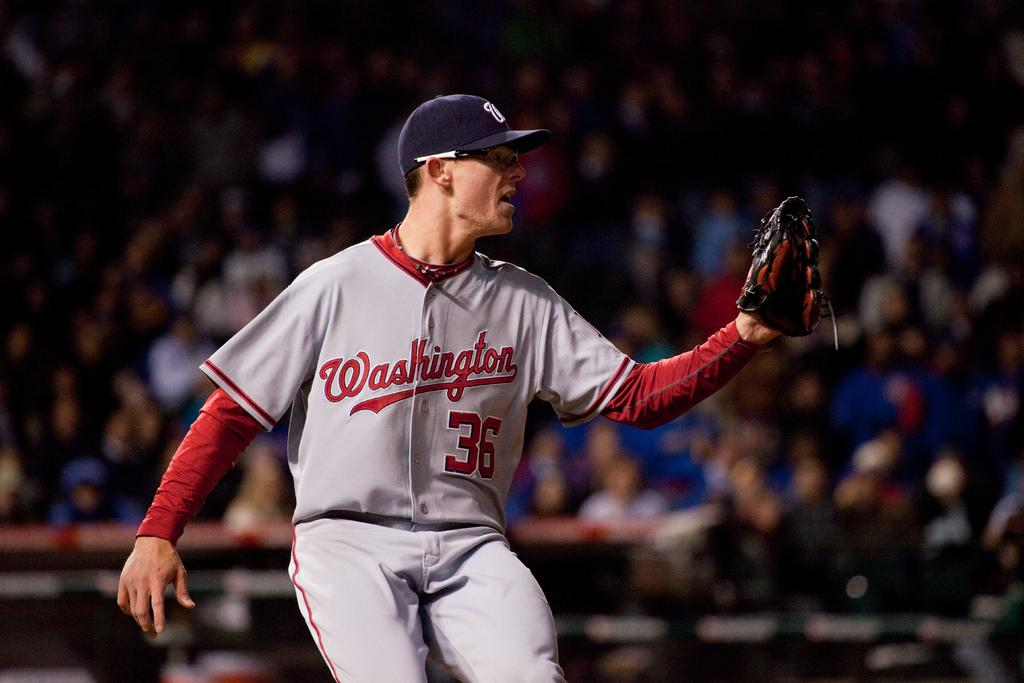<image>
Offer a succinct explanation of the picture presented. A baseball player wears a Washington uniform on the field. 